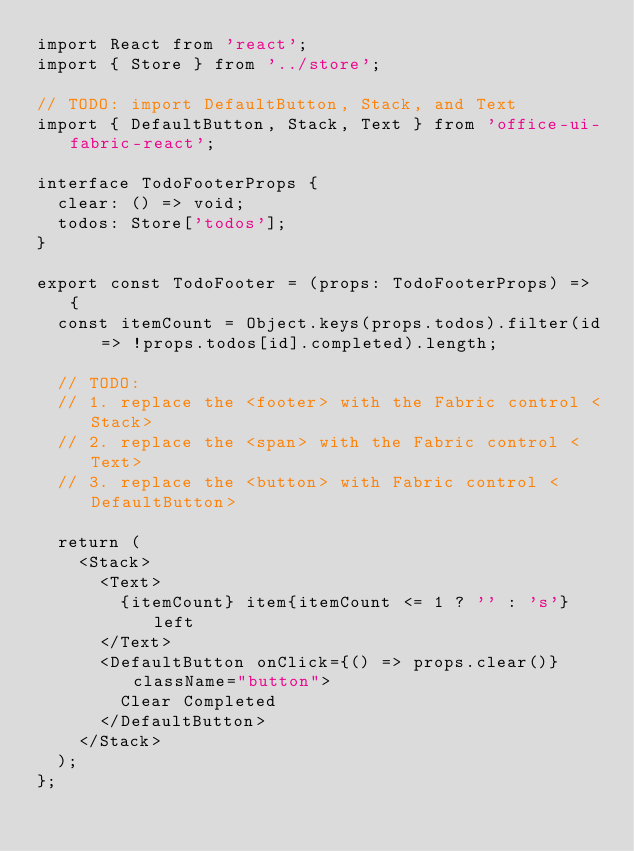<code> <loc_0><loc_0><loc_500><loc_500><_TypeScript_>import React from 'react';
import { Store } from '../store';

// TODO: import DefaultButton, Stack, and Text
import { DefaultButton, Stack, Text } from 'office-ui-fabric-react';

interface TodoFooterProps {
  clear: () => void;
  todos: Store['todos'];
}

export const TodoFooter = (props: TodoFooterProps) => {
  const itemCount = Object.keys(props.todos).filter(id => !props.todos[id].completed).length;

  // TODO:
  // 1. replace the <footer> with the Fabric control <Stack>
  // 2. replace the <span> with the Fabric control <Text>
  // 3. replace the <button> with Fabric control <DefaultButton>

  return (
    <Stack>
      <Text>
        {itemCount} item{itemCount <= 1 ? '' : 's'} left
      </Text>
      <DefaultButton onClick={() => props.clear()} className="button">
        Clear Completed
      </DefaultButton>
    </Stack>
  );
};
</code> 